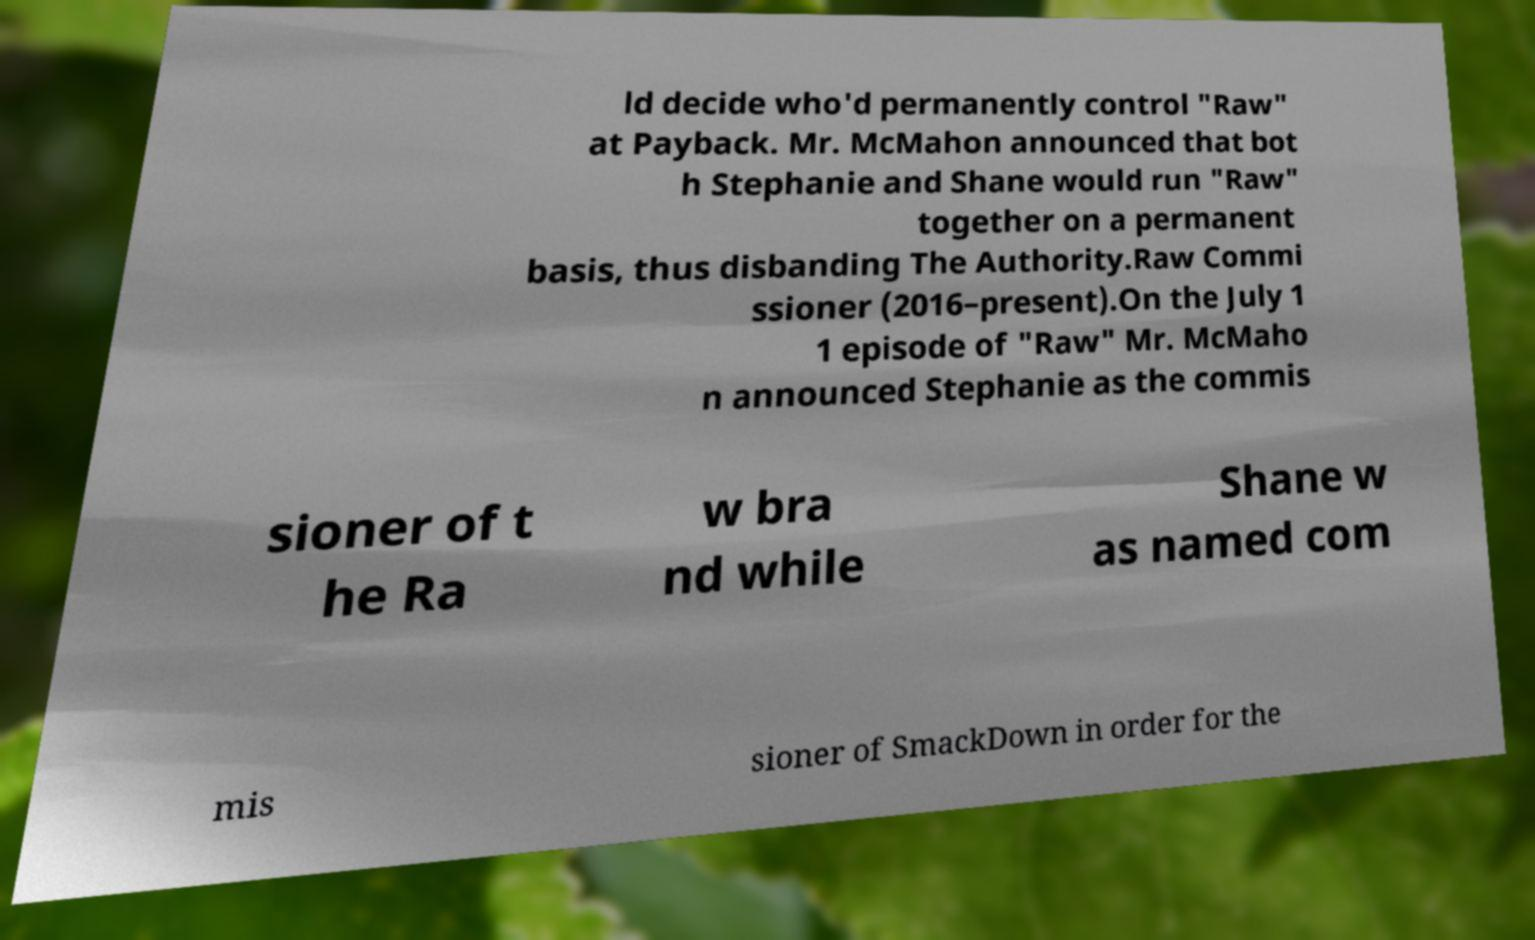Could you extract and type out the text from this image? ld decide who'd permanently control "Raw" at Payback. Mr. McMahon announced that bot h Stephanie and Shane would run "Raw" together on a permanent basis, thus disbanding The Authority.Raw Commi ssioner (2016–present).On the July 1 1 episode of "Raw" Mr. McMaho n announced Stephanie as the commis sioner of t he Ra w bra nd while Shane w as named com mis sioner of SmackDown in order for the 